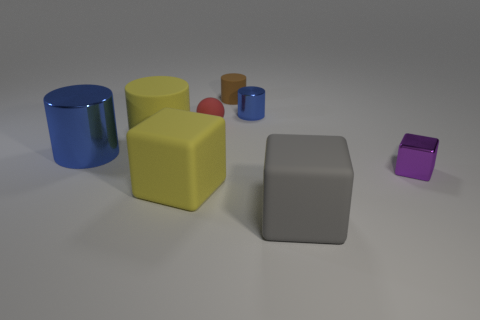There is a cylinder that is right of the yellow matte cube and in front of the tiny brown cylinder; how big is it?
Offer a terse response. Small. Are there fewer matte cylinders that are left of the tiny purple cube than blue metallic objects that are in front of the yellow matte block?
Offer a very short reply. No. Does the blue thing that is on the right side of the yellow cylinder have the same material as the yellow thing to the right of the large yellow cylinder?
Your answer should be very brief. No. There is a cylinder that is the same color as the large metallic object; what is it made of?
Your answer should be compact. Metal. What shape is the metal object that is both in front of the tiny red rubber thing and to the left of the tiny shiny cube?
Provide a short and direct response. Cylinder. There is a block on the right side of the large matte cube that is right of the tiny blue metal cylinder; what is it made of?
Offer a terse response. Metal. Is the number of blue objects greater than the number of objects?
Your answer should be compact. No. Does the big metal object have the same color as the small matte cylinder?
Ensure brevity in your answer.  No. There is a blue thing that is the same size as the gray matte block; what is it made of?
Keep it short and to the point. Metal. Do the small brown thing and the purple cube have the same material?
Ensure brevity in your answer.  No. 